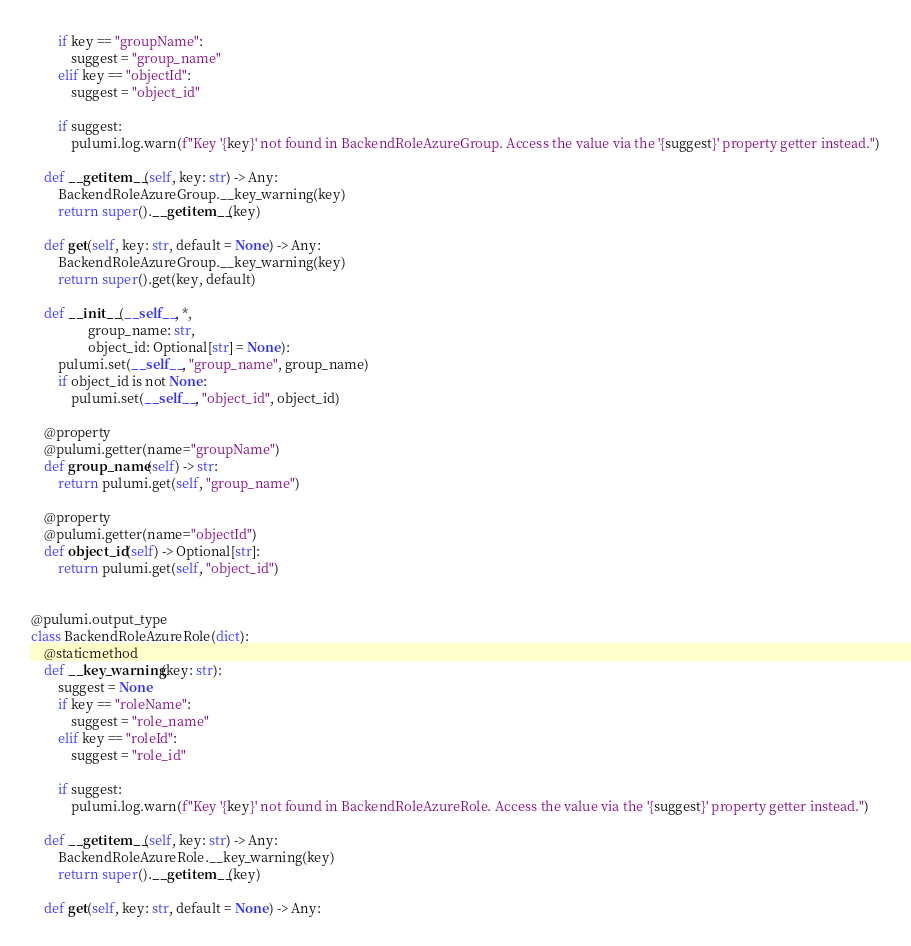Convert code to text. <code><loc_0><loc_0><loc_500><loc_500><_Python_>        if key == "groupName":
            suggest = "group_name"
        elif key == "objectId":
            suggest = "object_id"

        if suggest:
            pulumi.log.warn(f"Key '{key}' not found in BackendRoleAzureGroup. Access the value via the '{suggest}' property getter instead.")

    def __getitem__(self, key: str) -> Any:
        BackendRoleAzureGroup.__key_warning(key)
        return super().__getitem__(key)

    def get(self, key: str, default = None) -> Any:
        BackendRoleAzureGroup.__key_warning(key)
        return super().get(key, default)

    def __init__(__self__, *,
                 group_name: str,
                 object_id: Optional[str] = None):
        pulumi.set(__self__, "group_name", group_name)
        if object_id is not None:
            pulumi.set(__self__, "object_id", object_id)

    @property
    @pulumi.getter(name="groupName")
    def group_name(self) -> str:
        return pulumi.get(self, "group_name")

    @property
    @pulumi.getter(name="objectId")
    def object_id(self) -> Optional[str]:
        return pulumi.get(self, "object_id")


@pulumi.output_type
class BackendRoleAzureRole(dict):
    @staticmethod
    def __key_warning(key: str):
        suggest = None
        if key == "roleName":
            suggest = "role_name"
        elif key == "roleId":
            suggest = "role_id"

        if suggest:
            pulumi.log.warn(f"Key '{key}' not found in BackendRoleAzureRole. Access the value via the '{suggest}' property getter instead.")

    def __getitem__(self, key: str) -> Any:
        BackendRoleAzureRole.__key_warning(key)
        return super().__getitem__(key)

    def get(self, key: str, default = None) -> Any:</code> 